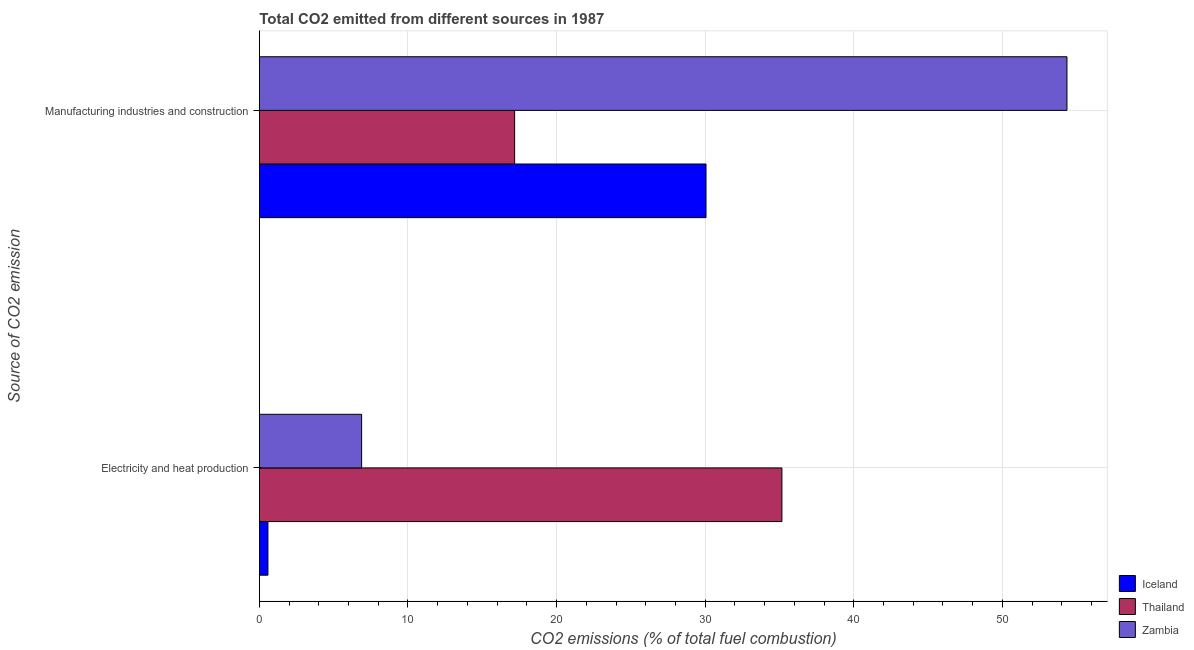How many different coloured bars are there?
Provide a succinct answer. 3. How many groups of bars are there?
Provide a short and direct response. 2. How many bars are there on the 1st tick from the bottom?
Your answer should be compact. 3. What is the label of the 2nd group of bars from the top?
Provide a succinct answer. Electricity and heat production. What is the co2 emissions due to electricity and heat production in Thailand?
Keep it short and to the point. 35.17. Across all countries, what is the maximum co2 emissions due to electricity and heat production?
Offer a very short reply. 35.17. Across all countries, what is the minimum co2 emissions due to manufacturing industries?
Give a very brief answer. 17.18. In which country was the co2 emissions due to manufacturing industries maximum?
Make the answer very short. Zambia. In which country was the co2 emissions due to manufacturing industries minimum?
Your answer should be compact. Thailand. What is the total co2 emissions due to manufacturing industries in the graph?
Provide a succinct answer. 101.58. What is the difference between the co2 emissions due to electricity and heat production in Iceland and that in Zambia?
Offer a very short reply. -6.31. What is the difference between the co2 emissions due to electricity and heat production in Thailand and the co2 emissions due to manufacturing industries in Zambia?
Keep it short and to the point. -19.18. What is the average co2 emissions due to electricity and heat production per country?
Make the answer very short. 14.21. What is the difference between the co2 emissions due to manufacturing industries and co2 emissions due to electricity and heat production in Zambia?
Make the answer very short. 47.46. What is the ratio of the co2 emissions due to manufacturing industries in Zambia to that in Thailand?
Ensure brevity in your answer.  3.16. What does the 1st bar from the bottom in Manufacturing industries and construction represents?
Your answer should be compact. Iceland. What is the difference between two consecutive major ticks on the X-axis?
Keep it short and to the point. 10. Does the graph contain any zero values?
Provide a short and direct response. No. Does the graph contain grids?
Provide a short and direct response. Yes. What is the title of the graph?
Give a very brief answer. Total CO2 emitted from different sources in 1987. Does "Swaziland" appear as one of the legend labels in the graph?
Your response must be concise. No. What is the label or title of the X-axis?
Keep it short and to the point. CO2 emissions (% of total fuel combustion). What is the label or title of the Y-axis?
Your response must be concise. Source of CO2 emission. What is the CO2 emissions (% of total fuel combustion) in Iceland in Electricity and heat production?
Give a very brief answer. 0.58. What is the CO2 emissions (% of total fuel combustion) of Thailand in Electricity and heat production?
Give a very brief answer. 35.17. What is the CO2 emissions (% of total fuel combustion) in Zambia in Electricity and heat production?
Your answer should be compact. 6.88. What is the CO2 emissions (% of total fuel combustion) in Iceland in Manufacturing industries and construction?
Offer a terse response. 30.06. What is the CO2 emissions (% of total fuel combustion) of Thailand in Manufacturing industries and construction?
Ensure brevity in your answer.  17.18. What is the CO2 emissions (% of total fuel combustion) in Zambia in Manufacturing industries and construction?
Your answer should be very brief. 54.35. Across all Source of CO2 emission, what is the maximum CO2 emissions (% of total fuel combustion) in Iceland?
Your answer should be compact. 30.06. Across all Source of CO2 emission, what is the maximum CO2 emissions (% of total fuel combustion) of Thailand?
Ensure brevity in your answer.  35.17. Across all Source of CO2 emission, what is the maximum CO2 emissions (% of total fuel combustion) in Zambia?
Offer a terse response. 54.35. Across all Source of CO2 emission, what is the minimum CO2 emissions (% of total fuel combustion) in Iceland?
Make the answer very short. 0.58. Across all Source of CO2 emission, what is the minimum CO2 emissions (% of total fuel combustion) of Thailand?
Provide a short and direct response. 17.18. Across all Source of CO2 emission, what is the minimum CO2 emissions (% of total fuel combustion) in Zambia?
Offer a very short reply. 6.88. What is the total CO2 emissions (% of total fuel combustion) in Iceland in the graph?
Your answer should be compact. 30.64. What is the total CO2 emissions (% of total fuel combustion) in Thailand in the graph?
Provide a succinct answer. 52.34. What is the total CO2 emissions (% of total fuel combustion) of Zambia in the graph?
Offer a terse response. 61.23. What is the difference between the CO2 emissions (% of total fuel combustion) in Iceland in Electricity and heat production and that in Manufacturing industries and construction?
Make the answer very short. -29.48. What is the difference between the CO2 emissions (% of total fuel combustion) in Thailand in Electricity and heat production and that in Manufacturing industries and construction?
Give a very brief answer. 17.99. What is the difference between the CO2 emissions (% of total fuel combustion) of Zambia in Electricity and heat production and that in Manufacturing industries and construction?
Make the answer very short. -47.46. What is the difference between the CO2 emissions (% of total fuel combustion) in Iceland in Electricity and heat production and the CO2 emissions (% of total fuel combustion) in Thailand in Manufacturing industries and construction?
Provide a short and direct response. -16.6. What is the difference between the CO2 emissions (% of total fuel combustion) of Iceland in Electricity and heat production and the CO2 emissions (% of total fuel combustion) of Zambia in Manufacturing industries and construction?
Offer a very short reply. -53.77. What is the difference between the CO2 emissions (% of total fuel combustion) in Thailand in Electricity and heat production and the CO2 emissions (% of total fuel combustion) in Zambia in Manufacturing industries and construction?
Provide a succinct answer. -19.18. What is the average CO2 emissions (% of total fuel combustion) in Iceland per Source of CO2 emission?
Keep it short and to the point. 15.32. What is the average CO2 emissions (% of total fuel combustion) in Thailand per Source of CO2 emission?
Ensure brevity in your answer.  26.17. What is the average CO2 emissions (% of total fuel combustion) of Zambia per Source of CO2 emission?
Offer a very short reply. 30.62. What is the difference between the CO2 emissions (% of total fuel combustion) of Iceland and CO2 emissions (% of total fuel combustion) of Thailand in Electricity and heat production?
Make the answer very short. -34.59. What is the difference between the CO2 emissions (% of total fuel combustion) of Iceland and CO2 emissions (% of total fuel combustion) of Zambia in Electricity and heat production?
Ensure brevity in your answer.  -6.31. What is the difference between the CO2 emissions (% of total fuel combustion) in Thailand and CO2 emissions (% of total fuel combustion) in Zambia in Electricity and heat production?
Offer a terse response. 28.28. What is the difference between the CO2 emissions (% of total fuel combustion) of Iceland and CO2 emissions (% of total fuel combustion) of Thailand in Manufacturing industries and construction?
Your answer should be compact. 12.88. What is the difference between the CO2 emissions (% of total fuel combustion) of Iceland and CO2 emissions (% of total fuel combustion) of Zambia in Manufacturing industries and construction?
Make the answer very short. -24.29. What is the difference between the CO2 emissions (% of total fuel combustion) of Thailand and CO2 emissions (% of total fuel combustion) of Zambia in Manufacturing industries and construction?
Your response must be concise. -37.17. What is the ratio of the CO2 emissions (% of total fuel combustion) of Iceland in Electricity and heat production to that in Manufacturing industries and construction?
Keep it short and to the point. 0.02. What is the ratio of the CO2 emissions (% of total fuel combustion) of Thailand in Electricity and heat production to that in Manufacturing industries and construction?
Ensure brevity in your answer.  2.05. What is the ratio of the CO2 emissions (% of total fuel combustion) in Zambia in Electricity and heat production to that in Manufacturing industries and construction?
Offer a very short reply. 0.13. What is the difference between the highest and the second highest CO2 emissions (% of total fuel combustion) in Iceland?
Your answer should be compact. 29.48. What is the difference between the highest and the second highest CO2 emissions (% of total fuel combustion) of Thailand?
Offer a very short reply. 17.99. What is the difference between the highest and the second highest CO2 emissions (% of total fuel combustion) of Zambia?
Offer a terse response. 47.46. What is the difference between the highest and the lowest CO2 emissions (% of total fuel combustion) in Iceland?
Provide a short and direct response. 29.48. What is the difference between the highest and the lowest CO2 emissions (% of total fuel combustion) of Thailand?
Provide a short and direct response. 17.99. What is the difference between the highest and the lowest CO2 emissions (% of total fuel combustion) in Zambia?
Ensure brevity in your answer.  47.46. 